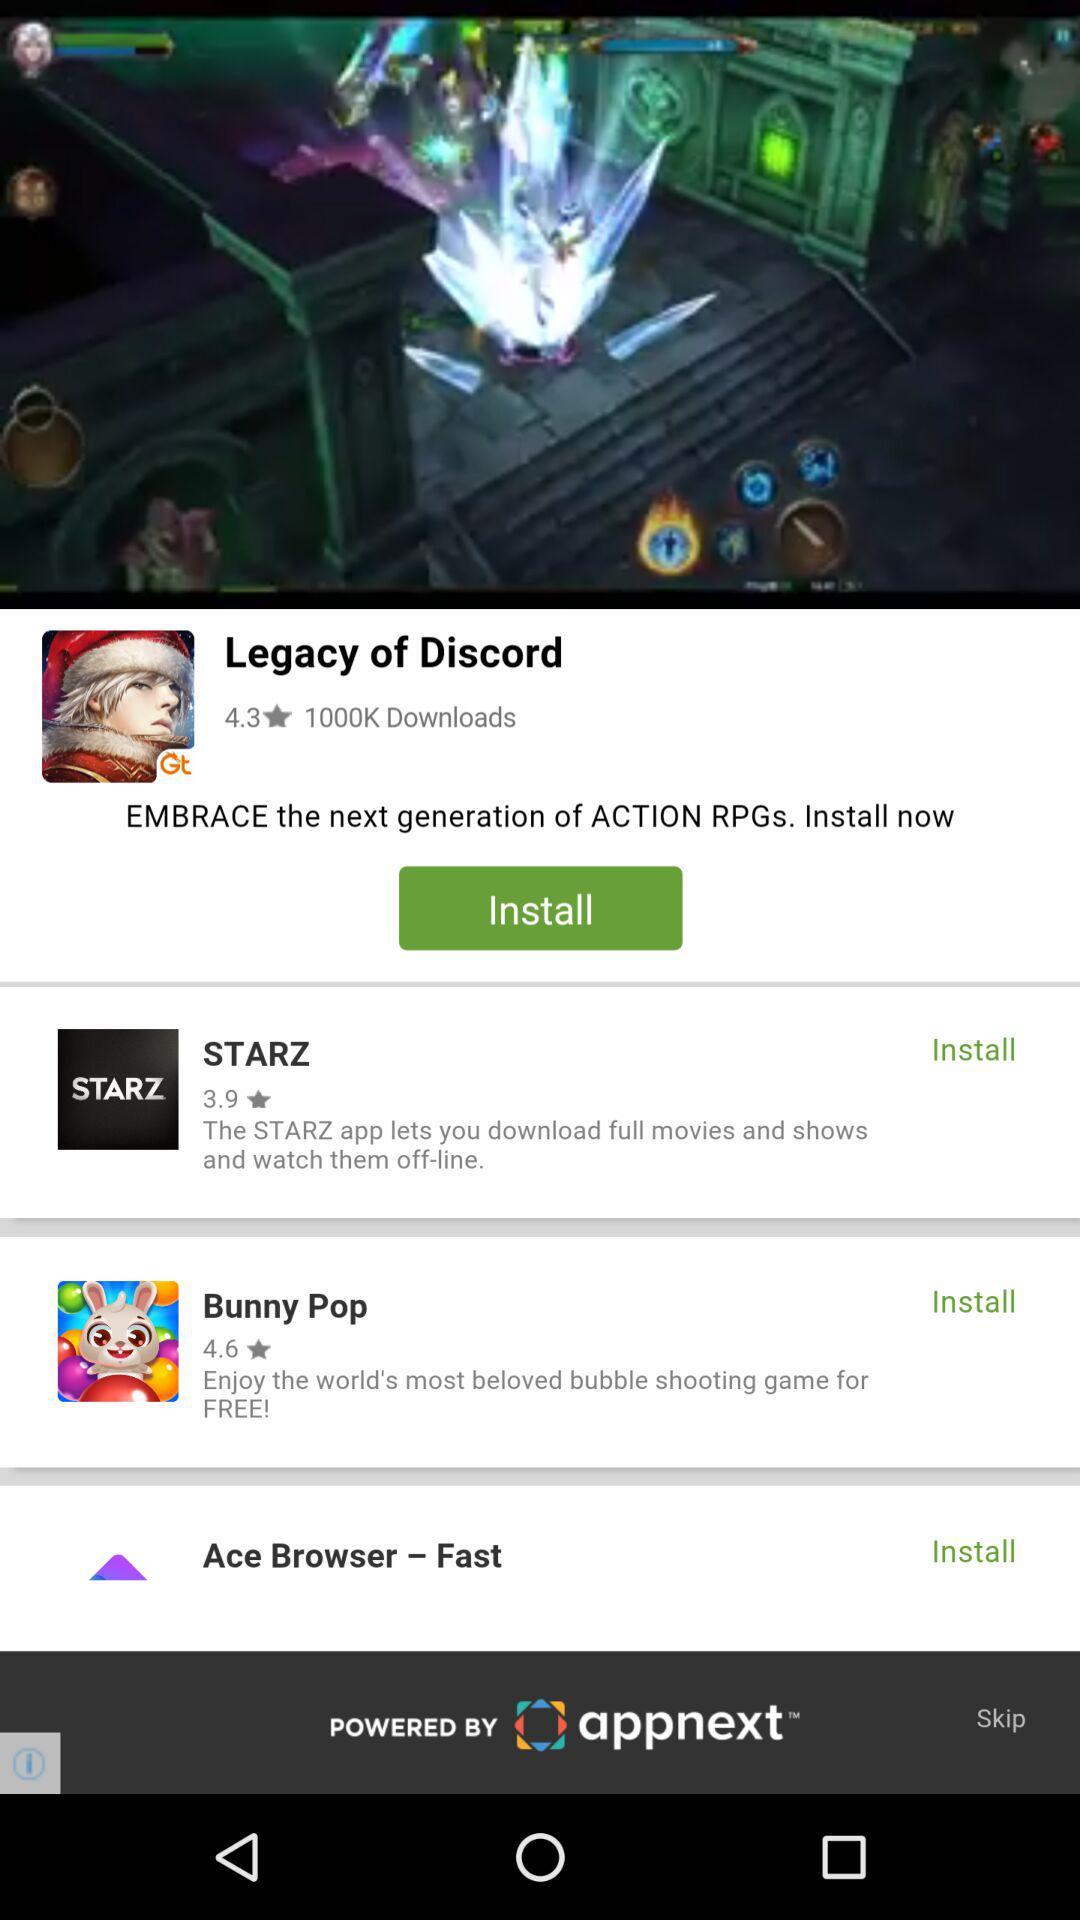What is the rating of "Legacy of Discord"? The rating of "Legacy of Discord" is 4.3. 